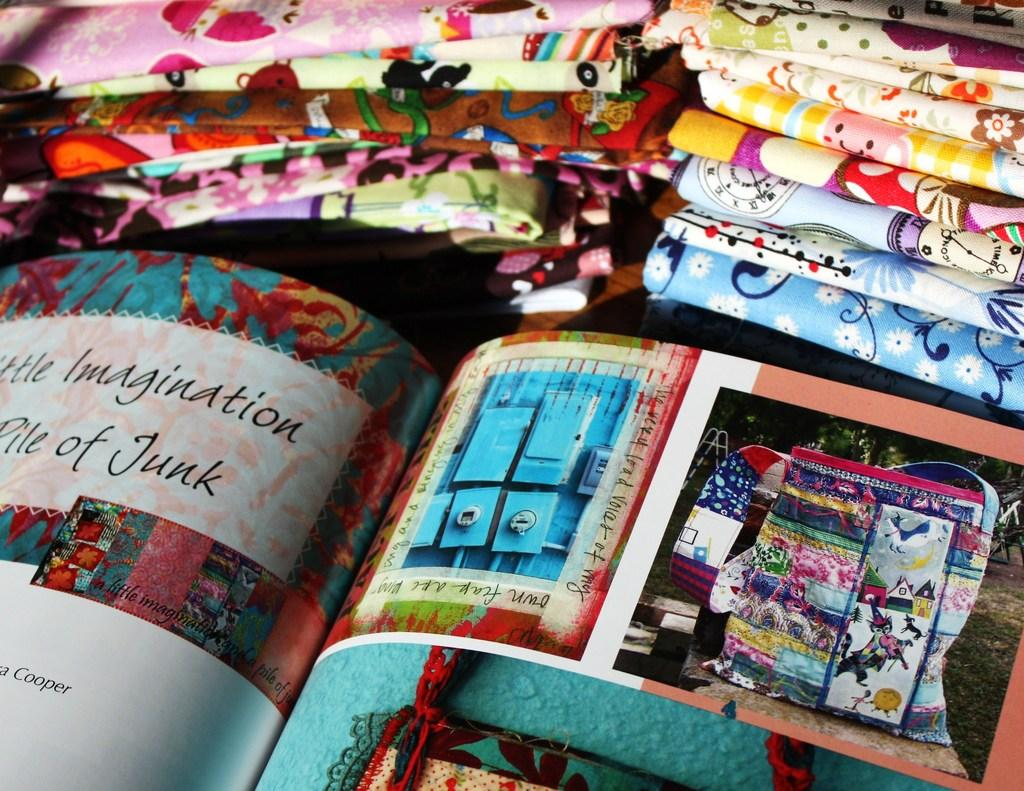<image>
Render a clear and concise summary of the photo. a book next to fabric that says 'imagination pile of junk' on it 